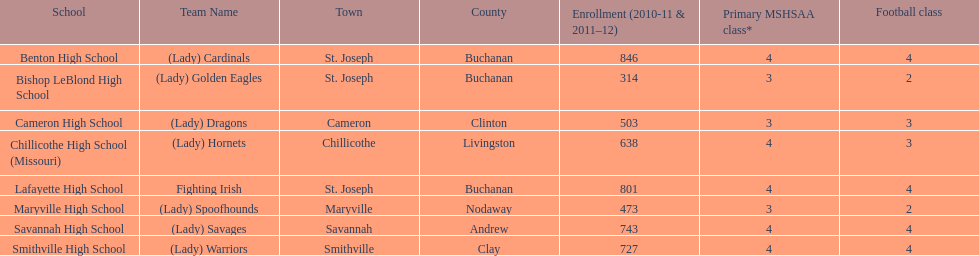Does lafayette high school or benton high school possess green and grey as their hues? Lafayette High School. 